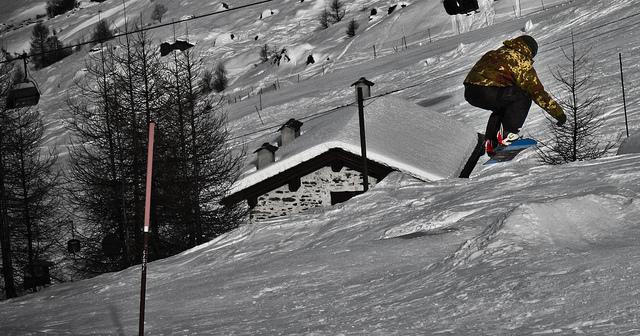How many red bikes are there?
Give a very brief answer. 0. 